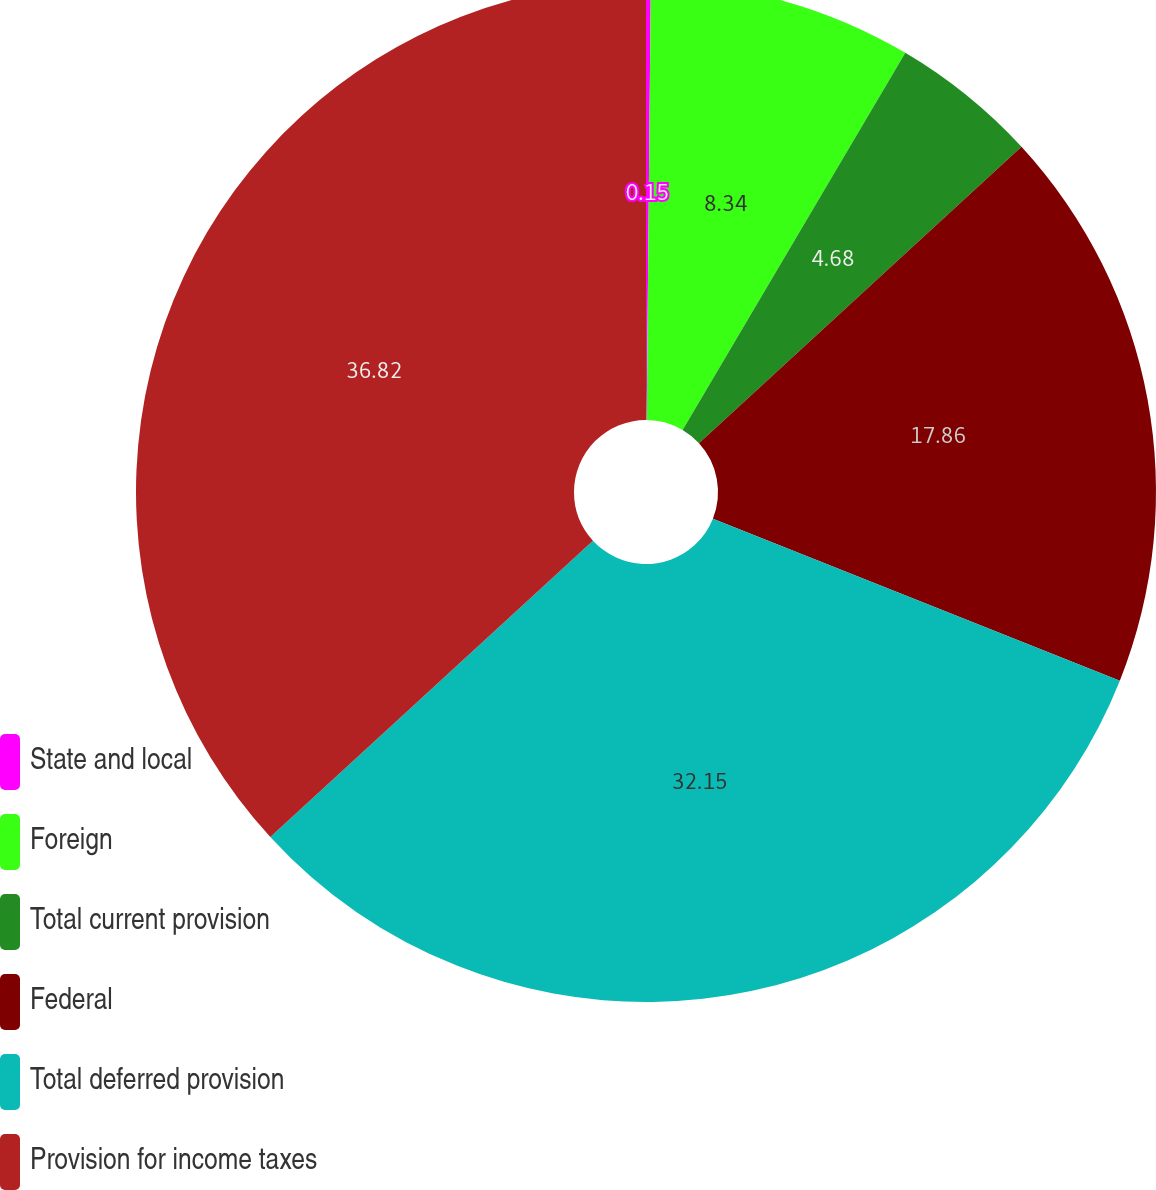Convert chart to OTSL. <chart><loc_0><loc_0><loc_500><loc_500><pie_chart><fcel>State and local<fcel>Foreign<fcel>Total current provision<fcel>Federal<fcel>Total deferred provision<fcel>Provision for income taxes<nl><fcel>0.15%<fcel>8.34%<fcel>4.68%<fcel>17.86%<fcel>32.15%<fcel>36.82%<nl></chart> 